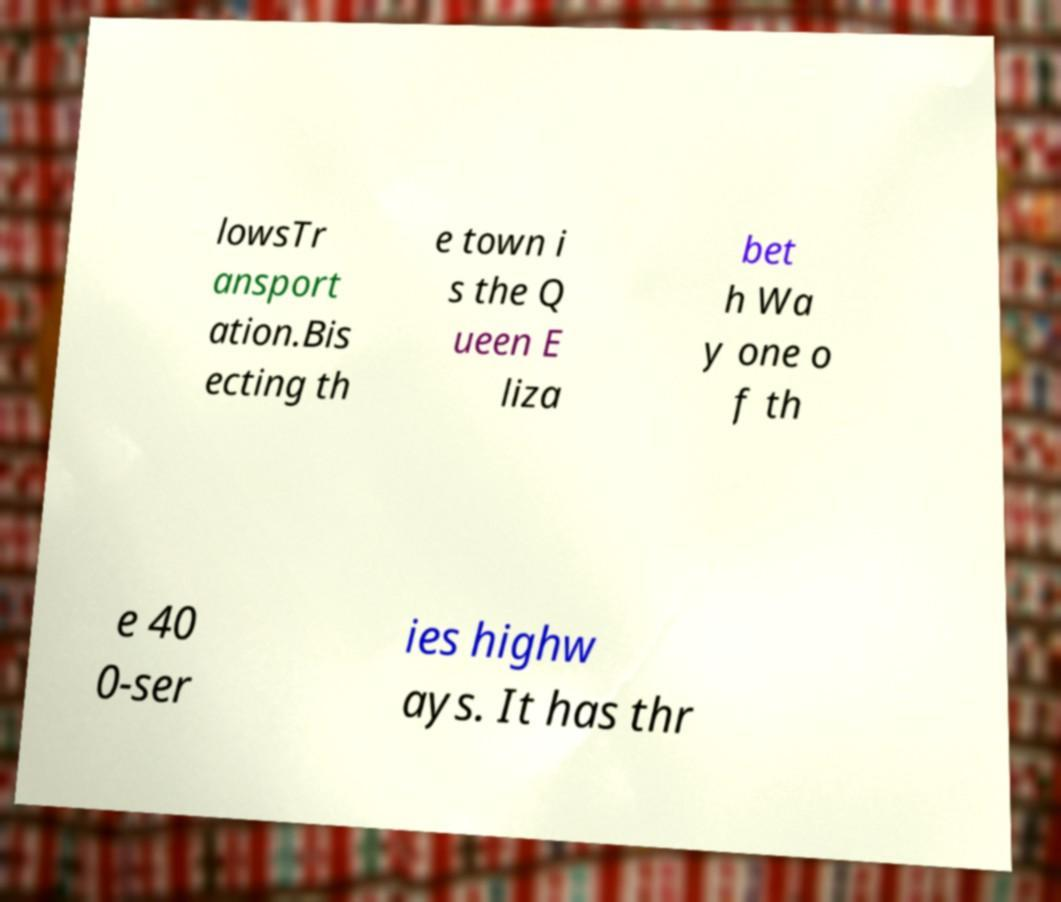Could you extract and type out the text from this image? lowsTr ansport ation.Bis ecting th e town i s the Q ueen E liza bet h Wa y one o f th e 40 0-ser ies highw ays. It has thr 